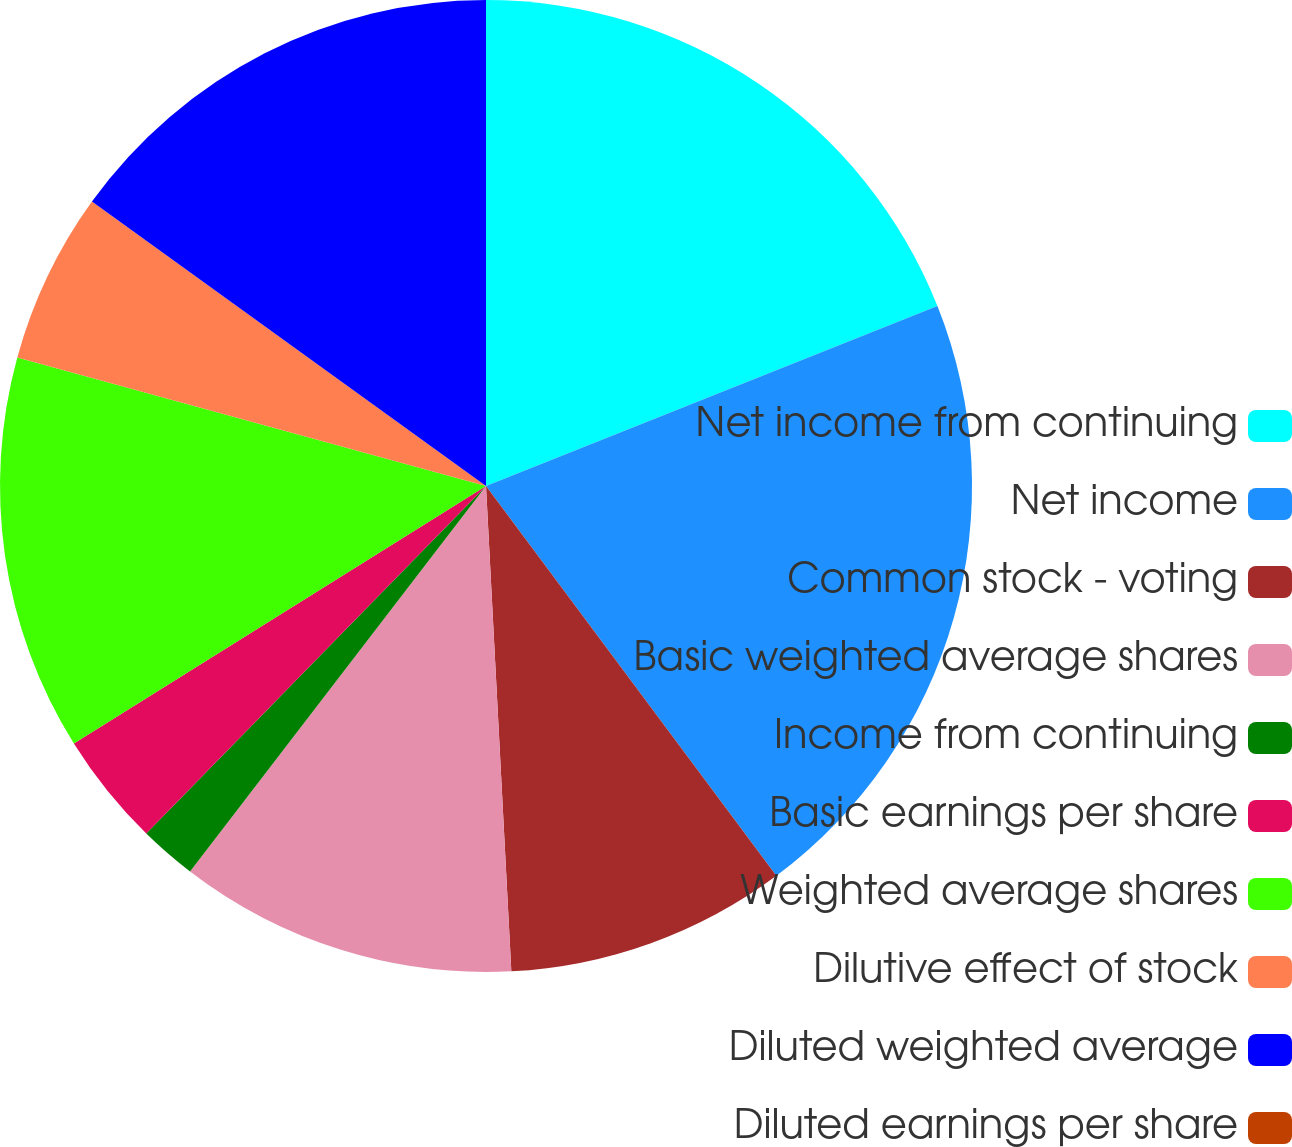Convert chart to OTSL. <chart><loc_0><loc_0><loc_500><loc_500><pie_chart><fcel>Net income from continuing<fcel>Net income<fcel>Common stock - voting<fcel>Basic weighted average shares<fcel>Income from continuing<fcel>Basic earnings per share<fcel>Weighted average shares<fcel>Dilutive effect of stock<fcel>Diluted weighted average<fcel>Diluted earnings per share<nl><fcel>18.96%<fcel>20.85%<fcel>9.36%<fcel>11.25%<fcel>1.9%<fcel>3.79%<fcel>13.15%<fcel>5.69%<fcel>15.05%<fcel>0.0%<nl></chart> 